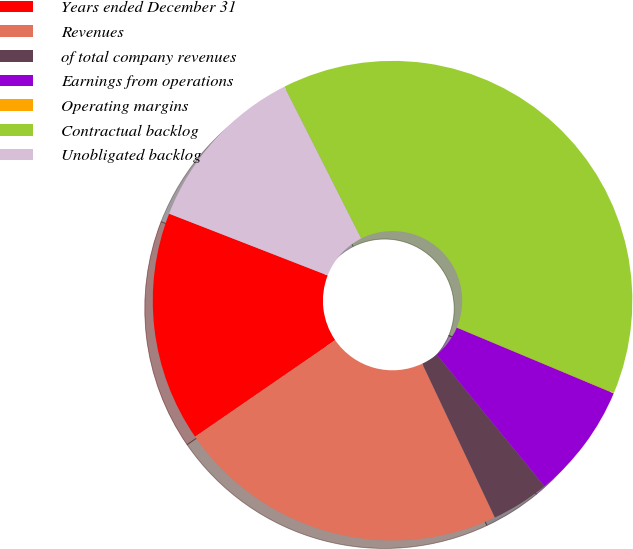<chart> <loc_0><loc_0><loc_500><loc_500><pie_chart><fcel>Years ended December 31<fcel>Revenues<fcel>of total company revenues<fcel>Earnings from operations<fcel>Operating margins<fcel>Contractual backlog<fcel>Unobligated backlog<nl><fcel>15.51%<fcel>22.42%<fcel>3.9%<fcel>7.77%<fcel>0.03%<fcel>38.74%<fcel>11.64%<nl></chart> 